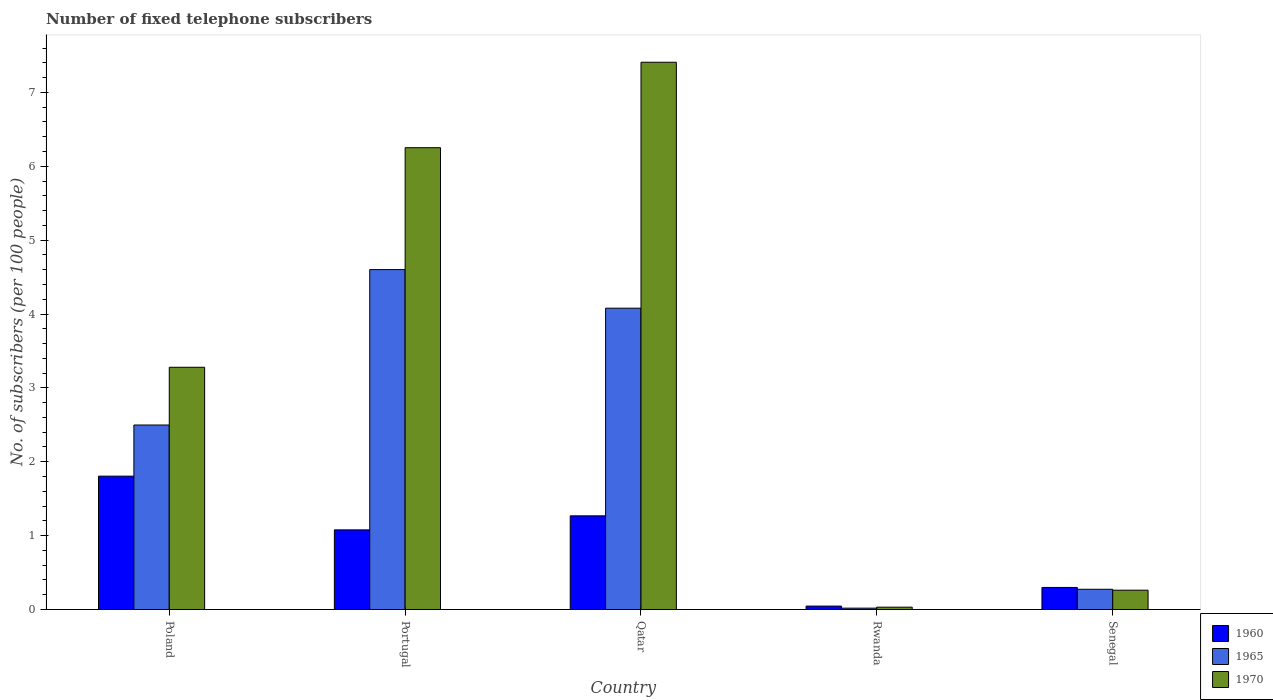Are the number of bars per tick equal to the number of legend labels?
Ensure brevity in your answer.  Yes. How many bars are there on the 4th tick from the left?
Provide a short and direct response. 3. How many bars are there on the 3rd tick from the right?
Make the answer very short. 3. What is the label of the 4th group of bars from the left?
Your answer should be very brief. Rwanda. What is the number of fixed telephone subscribers in 1970 in Qatar?
Your answer should be compact. 7.41. Across all countries, what is the maximum number of fixed telephone subscribers in 1960?
Your response must be concise. 1.81. Across all countries, what is the minimum number of fixed telephone subscribers in 1965?
Offer a very short reply. 0.02. In which country was the number of fixed telephone subscribers in 1965 maximum?
Offer a terse response. Portugal. In which country was the number of fixed telephone subscribers in 1970 minimum?
Give a very brief answer. Rwanda. What is the total number of fixed telephone subscribers in 1970 in the graph?
Provide a succinct answer. 17.23. What is the difference between the number of fixed telephone subscribers in 1965 in Poland and that in Qatar?
Give a very brief answer. -1.58. What is the difference between the number of fixed telephone subscribers in 1960 in Portugal and the number of fixed telephone subscribers in 1970 in Senegal?
Your answer should be very brief. 0.82. What is the average number of fixed telephone subscribers in 1965 per country?
Give a very brief answer. 2.29. What is the difference between the number of fixed telephone subscribers of/in 1970 and number of fixed telephone subscribers of/in 1965 in Poland?
Offer a terse response. 0.78. What is the ratio of the number of fixed telephone subscribers in 1960 in Portugal to that in Senegal?
Give a very brief answer. 3.61. What is the difference between the highest and the second highest number of fixed telephone subscribers in 1960?
Offer a very short reply. 0.54. What is the difference between the highest and the lowest number of fixed telephone subscribers in 1970?
Ensure brevity in your answer.  7.38. In how many countries, is the number of fixed telephone subscribers in 1960 greater than the average number of fixed telephone subscribers in 1960 taken over all countries?
Give a very brief answer. 3. Is the sum of the number of fixed telephone subscribers in 1970 in Poland and Portugal greater than the maximum number of fixed telephone subscribers in 1960 across all countries?
Provide a short and direct response. Yes. Is it the case that in every country, the sum of the number of fixed telephone subscribers in 1960 and number of fixed telephone subscribers in 1965 is greater than the number of fixed telephone subscribers in 1970?
Provide a succinct answer. No. How many countries are there in the graph?
Make the answer very short. 5. Are the values on the major ticks of Y-axis written in scientific E-notation?
Your response must be concise. No. Does the graph contain any zero values?
Offer a terse response. No. Does the graph contain grids?
Your response must be concise. No. Where does the legend appear in the graph?
Offer a terse response. Bottom right. How many legend labels are there?
Ensure brevity in your answer.  3. What is the title of the graph?
Make the answer very short. Number of fixed telephone subscribers. What is the label or title of the X-axis?
Provide a succinct answer. Country. What is the label or title of the Y-axis?
Make the answer very short. No. of subscribers (per 100 people). What is the No. of subscribers (per 100 people) in 1960 in Poland?
Give a very brief answer. 1.81. What is the No. of subscribers (per 100 people) of 1965 in Poland?
Your answer should be very brief. 2.5. What is the No. of subscribers (per 100 people) of 1970 in Poland?
Keep it short and to the point. 3.28. What is the No. of subscribers (per 100 people) of 1960 in Portugal?
Provide a succinct answer. 1.08. What is the No. of subscribers (per 100 people) of 1965 in Portugal?
Provide a short and direct response. 4.6. What is the No. of subscribers (per 100 people) in 1970 in Portugal?
Your response must be concise. 6.25. What is the No. of subscribers (per 100 people) in 1960 in Qatar?
Offer a terse response. 1.27. What is the No. of subscribers (per 100 people) of 1965 in Qatar?
Provide a succinct answer. 4.08. What is the No. of subscribers (per 100 people) in 1970 in Qatar?
Your answer should be very brief. 7.41. What is the No. of subscribers (per 100 people) of 1960 in Rwanda?
Offer a terse response. 0.05. What is the No. of subscribers (per 100 people) of 1965 in Rwanda?
Your answer should be very brief. 0.02. What is the No. of subscribers (per 100 people) in 1970 in Rwanda?
Your answer should be very brief. 0.03. What is the No. of subscribers (per 100 people) in 1960 in Senegal?
Your answer should be very brief. 0.3. What is the No. of subscribers (per 100 people) in 1965 in Senegal?
Offer a terse response. 0.27. What is the No. of subscribers (per 100 people) in 1970 in Senegal?
Offer a very short reply. 0.26. Across all countries, what is the maximum No. of subscribers (per 100 people) in 1960?
Give a very brief answer. 1.81. Across all countries, what is the maximum No. of subscribers (per 100 people) in 1965?
Your response must be concise. 4.6. Across all countries, what is the maximum No. of subscribers (per 100 people) in 1970?
Provide a short and direct response. 7.41. Across all countries, what is the minimum No. of subscribers (per 100 people) in 1960?
Offer a terse response. 0.05. Across all countries, what is the minimum No. of subscribers (per 100 people) in 1965?
Provide a succinct answer. 0.02. Across all countries, what is the minimum No. of subscribers (per 100 people) of 1970?
Keep it short and to the point. 0.03. What is the total No. of subscribers (per 100 people) of 1960 in the graph?
Give a very brief answer. 4.5. What is the total No. of subscribers (per 100 people) in 1965 in the graph?
Make the answer very short. 11.47. What is the total No. of subscribers (per 100 people) in 1970 in the graph?
Provide a succinct answer. 17.23. What is the difference between the No. of subscribers (per 100 people) in 1960 in Poland and that in Portugal?
Your response must be concise. 0.73. What is the difference between the No. of subscribers (per 100 people) in 1965 in Poland and that in Portugal?
Ensure brevity in your answer.  -2.1. What is the difference between the No. of subscribers (per 100 people) of 1970 in Poland and that in Portugal?
Your response must be concise. -2.97. What is the difference between the No. of subscribers (per 100 people) of 1960 in Poland and that in Qatar?
Provide a succinct answer. 0.54. What is the difference between the No. of subscribers (per 100 people) of 1965 in Poland and that in Qatar?
Provide a short and direct response. -1.58. What is the difference between the No. of subscribers (per 100 people) of 1970 in Poland and that in Qatar?
Offer a very short reply. -4.13. What is the difference between the No. of subscribers (per 100 people) of 1960 in Poland and that in Rwanda?
Provide a short and direct response. 1.76. What is the difference between the No. of subscribers (per 100 people) of 1965 in Poland and that in Rwanda?
Give a very brief answer. 2.48. What is the difference between the No. of subscribers (per 100 people) in 1970 in Poland and that in Rwanda?
Ensure brevity in your answer.  3.25. What is the difference between the No. of subscribers (per 100 people) in 1960 in Poland and that in Senegal?
Give a very brief answer. 1.51. What is the difference between the No. of subscribers (per 100 people) of 1965 in Poland and that in Senegal?
Offer a terse response. 2.22. What is the difference between the No. of subscribers (per 100 people) in 1970 in Poland and that in Senegal?
Provide a short and direct response. 3.02. What is the difference between the No. of subscribers (per 100 people) of 1960 in Portugal and that in Qatar?
Offer a terse response. -0.19. What is the difference between the No. of subscribers (per 100 people) in 1965 in Portugal and that in Qatar?
Your response must be concise. 0.52. What is the difference between the No. of subscribers (per 100 people) in 1970 in Portugal and that in Qatar?
Offer a very short reply. -1.16. What is the difference between the No. of subscribers (per 100 people) of 1960 in Portugal and that in Rwanda?
Your answer should be very brief. 1.03. What is the difference between the No. of subscribers (per 100 people) in 1965 in Portugal and that in Rwanda?
Your response must be concise. 4.58. What is the difference between the No. of subscribers (per 100 people) in 1970 in Portugal and that in Rwanda?
Your answer should be very brief. 6.22. What is the difference between the No. of subscribers (per 100 people) in 1960 in Portugal and that in Senegal?
Provide a short and direct response. 0.78. What is the difference between the No. of subscribers (per 100 people) of 1965 in Portugal and that in Senegal?
Give a very brief answer. 4.33. What is the difference between the No. of subscribers (per 100 people) of 1970 in Portugal and that in Senegal?
Your response must be concise. 5.99. What is the difference between the No. of subscribers (per 100 people) of 1960 in Qatar and that in Rwanda?
Offer a very short reply. 1.22. What is the difference between the No. of subscribers (per 100 people) of 1965 in Qatar and that in Rwanda?
Ensure brevity in your answer.  4.06. What is the difference between the No. of subscribers (per 100 people) in 1970 in Qatar and that in Rwanda?
Provide a succinct answer. 7.38. What is the difference between the No. of subscribers (per 100 people) in 1960 in Qatar and that in Senegal?
Ensure brevity in your answer.  0.97. What is the difference between the No. of subscribers (per 100 people) of 1965 in Qatar and that in Senegal?
Make the answer very short. 3.8. What is the difference between the No. of subscribers (per 100 people) of 1970 in Qatar and that in Senegal?
Your answer should be compact. 7.15. What is the difference between the No. of subscribers (per 100 people) of 1960 in Rwanda and that in Senegal?
Provide a short and direct response. -0.25. What is the difference between the No. of subscribers (per 100 people) in 1965 in Rwanda and that in Senegal?
Give a very brief answer. -0.26. What is the difference between the No. of subscribers (per 100 people) in 1970 in Rwanda and that in Senegal?
Make the answer very short. -0.23. What is the difference between the No. of subscribers (per 100 people) in 1960 in Poland and the No. of subscribers (per 100 people) in 1965 in Portugal?
Give a very brief answer. -2.8. What is the difference between the No. of subscribers (per 100 people) of 1960 in Poland and the No. of subscribers (per 100 people) of 1970 in Portugal?
Make the answer very short. -4.45. What is the difference between the No. of subscribers (per 100 people) in 1965 in Poland and the No. of subscribers (per 100 people) in 1970 in Portugal?
Offer a terse response. -3.75. What is the difference between the No. of subscribers (per 100 people) of 1960 in Poland and the No. of subscribers (per 100 people) of 1965 in Qatar?
Provide a succinct answer. -2.27. What is the difference between the No. of subscribers (per 100 people) in 1960 in Poland and the No. of subscribers (per 100 people) in 1970 in Qatar?
Give a very brief answer. -5.6. What is the difference between the No. of subscribers (per 100 people) of 1965 in Poland and the No. of subscribers (per 100 people) of 1970 in Qatar?
Your answer should be compact. -4.91. What is the difference between the No. of subscribers (per 100 people) in 1960 in Poland and the No. of subscribers (per 100 people) in 1965 in Rwanda?
Offer a terse response. 1.79. What is the difference between the No. of subscribers (per 100 people) in 1960 in Poland and the No. of subscribers (per 100 people) in 1970 in Rwanda?
Provide a succinct answer. 1.77. What is the difference between the No. of subscribers (per 100 people) of 1965 in Poland and the No. of subscribers (per 100 people) of 1970 in Rwanda?
Your answer should be very brief. 2.47. What is the difference between the No. of subscribers (per 100 people) of 1960 in Poland and the No. of subscribers (per 100 people) of 1965 in Senegal?
Provide a short and direct response. 1.53. What is the difference between the No. of subscribers (per 100 people) of 1960 in Poland and the No. of subscribers (per 100 people) of 1970 in Senegal?
Your answer should be very brief. 1.54. What is the difference between the No. of subscribers (per 100 people) of 1965 in Poland and the No. of subscribers (per 100 people) of 1970 in Senegal?
Ensure brevity in your answer.  2.24. What is the difference between the No. of subscribers (per 100 people) of 1960 in Portugal and the No. of subscribers (per 100 people) of 1965 in Qatar?
Your response must be concise. -3. What is the difference between the No. of subscribers (per 100 people) in 1960 in Portugal and the No. of subscribers (per 100 people) in 1970 in Qatar?
Your response must be concise. -6.33. What is the difference between the No. of subscribers (per 100 people) in 1965 in Portugal and the No. of subscribers (per 100 people) in 1970 in Qatar?
Provide a succinct answer. -2.81. What is the difference between the No. of subscribers (per 100 people) in 1960 in Portugal and the No. of subscribers (per 100 people) in 1965 in Rwanda?
Your response must be concise. 1.06. What is the difference between the No. of subscribers (per 100 people) in 1960 in Portugal and the No. of subscribers (per 100 people) in 1970 in Rwanda?
Keep it short and to the point. 1.05. What is the difference between the No. of subscribers (per 100 people) in 1965 in Portugal and the No. of subscribers (per 100 people) in 1970 in Rwanda?
Your answer should be very brief. 4.57. What is the difference between the No. of subscribers (per 100 people) in 1960 in Portugal and the No. of subscribers (per 100 people) in 1965 in Senegal?
Your answer should be very brief. 0.8. What is the difference between the No. of subscribers (per 100 people) in 1960 in Portugal and the No. of subscribers (per 100 people) in 1970 in Senegal?
Keep it short and to the point. 0.82. What is the difference between the No. of subscribers (per 100 people) in 1965 in Portugal and the No. of subscribers (per 100 people) in 1970 in Senegal?
Provide a short and direct response. 4.34. What is the difference between the No. of subscribers (per 100 people) in 1960 in Qatar and the No. of subscribers (per 100 people) in 1965 in Rwanda?
Keep it short and to the point. 1.25. What is the difference between the No. of subscribers (per 100 people) of 1960 in Qatar and the No. of subscribers (per 100 people) of 1970 in Rwanda?
Provide a short and direct response. 1.24. What is the difference between the No. of subscribers (per 100 people) of 1965 in Qatar and the No. of subscribers (per 100 people) of 1970 in Rwanda?
Provide a short and direct response. 4.05. What is the difference between the No. of subscribers (per 100 people) in 1960 in Qatar and the No. of subscribers (per 100 people) in 1970 in Senegal?
Offer a very short reply. 1.01. What is the difference between the No. of subscribers (per 100 people) in 1965 in Qatar and the No. of subscribers (per 100 people) in 1970 in Senegal?
Offer a very short reply. 3.82. What is the difference between the No. of subscribers (per 100 people) of 1960 in Rwanda and the No. of subscribers (per 100 people) of 1965 in Senegal?
Provide a short and direct response. -0.23. What is the difference between the No. of subscribers (per 100 people) of 1960 in Rwanda and the No. of subscribers (per 100 people) of 1970 in Senegal?
Offer a very short reply. -0.22. What is the difference between the No. of subscribers (per 100 people) in 1965 in Rwanda and the No. of subscribers (per 100 people) in 1970 in Senegal?
Your answer should be very brief. -0.24. What is the average No. of subscribers (per 100 people) of 1960 per country?
Your answer should be compact. 0.9. What is the average No. of subscribers (per 100 people) of 1965 per country?
Make the answer very short. 2.29. What is the average No. of subscribers (per 100 people) of 1970 per country?
Your response must be concise. 3.45. What is the difference between the No. of subscribers (per 100 people) in 1960 and No. of subscribers (per 100 people) in 1965 in Poland?
Make the answer very short. -0.69. What is the difference between the No. of subscribers (per 100 people) of 1960 and No. of subscribers (per 100 people) of 1970 in Poland?
Ensure brevity in your answer.  -1.47. What is the difference between the No. of subscribers (per 100 people) in 1965 and No. of subscribers (per 100 people) in 1970 in Poland?
Make the answer very short. -0.78. What is the difference between the No. of subscribers (per 100 people) of 1960 and No. of subscribers (per 100 people) of 1965 in Portugal?
Make the answer very short. -3.52. What is the difference between the No. of subscribers (per 100 people) in 1960 and No. of subscribers (per 100 people) in 1970 in Portugal?
Keep it short and to the point. -5.17. What is the difference between the No. of subscribers (per 100 people) of 1965 and No. of subscribers (per 100 people) of 1970 in Portugal?
Offer a terse response. -1.65. What is the difference between the No. of subscribers (per 100 people) of 1960 and No. of subscribers (per 100 people) of 1965 in Qatar?
Provide a succinct answer. -2.81. What is the difference between the No. of subscribers (per 100 people) of 1960 and No. of subscribers (per 100 people) of 1970 in Qatar?
Your response must be concise. -6.14. What is the difference between the No. of subscribers (per 100 people) in 1965 and No. of subscribers (per 100 people) in 1970 in Qatar?
Offer a very short reply. -3.33. What is the difference between the No. of subscribers (per 100 people) in 1960 and No. of subscribers (per 100 people) in 1965 in Rwanda?
Keep it short and to the point. 0.03. What is the difference between the No. of subscribers (per 100 people) in 1960 and No. of subscribers (per 100 people) in 1970 in Rwanda?
Your answer should be compact. 0.01. What is the difference between the No. of subscribers (per 100 people) in 1965 and No. of subscribers (per 100 people) in 1970 in Rwanda?
Make the answer very short. -0.01. What is the difference between the No. of subscribers (per 100 people) of 1960 and No. of subscribers (per 100 people) of 1965 in Senegal?
Your answer should be compact. 0.02. What is the difference between the No. of subscribers (per 100 people) in 1960 and No. of subscribers (per 100 people) in 1970 in Senegal?
Ensure brevity in your answer.  0.04. What is the difference between the No. of subscribers (per 100 people) in 1965 and No. of subscribers (per 100 people) in 1970 in Senegal?
Make the answer very short. 0.01. What is the ratio of the No. of subscribers (per 100 people) of 1960 in Poland to that in Portugal?
Provide a succinct answer. 1.67. What is the ratio of the No. of subscribers (per 100 people) in 1965 in Poland to that in Portugal?
Your answer should be compact. 0.54. What is the ratio of the No. of subscribers (per 100 people) of 1970 in Poland to that in Portugal?
Offer a terse response. 0.52. What is the ratio of the No. of subscribers (per 100 people) in 1960 in Poland to that in Qatar?
Offer a very short reply. 1.42. What is the ratio of the No. of subscribers (per 100 people) in 1965 in Poland to that in Qatar?
Offer a terse response. 0.61. What is the ratio of the No. of subscribers (per 100 people) of 1970 in Poland to that in Qatar?
Your answer should be compact. 0.44. What is the ratio of the No. of subscribers (per 100 people) in 1960 in Poland to that in Rwanda?
Your answer should be very brief. 38.77. What is the ratio of the No. of subscribers (per 100 people) of 1965 in Poland to that in Rwanda?
Offer a terse response. 134.57. What is the ratio of the No. of subscribers (per 100 people) of 1970 in Poland to that in Rwanda?
Offer a terse response. 102.59. What is the ratio of the No. of subscribers (per 100 people) in 1960 in Poland to that in Senegal?
Your response must be concise. 6.04. What is the ratio of the No. of subscribers (per 100 people) in 1965 in Poland to that in Senegal?
Your answer should be very brief. 9.11. What is the ratio of the No. of subscribers (per 100 people) of 1970 in Poland to that in Senegal?
Provide a succinct answer. 12.53. What is the ratio of the No. of subscribers (per 100 people) of 1960 in Portugal to that in Qatar?
Give a very brief answer. 0.85. What is the ratio of the No. of subscribers (per 100 people) in 1965 in Portugal to that in Qatar?
Offer a very short reply. 1.13. What is the ratio of the No. of subscribers (per 100 people) in 1970 in Portugal to that in Qatar?
Ensure brevity in your answer.  0.84. What is the ratio of the No. of subscribers (per 100 people) of 1960 in Portugal to that in Rwanda?
Your answer should be very brief. 23.15. What is the ratio of the No. of subscribers (per 100 people) in 1965 in Portugal to that in Rwanda?
Your response must be concise. 247.93. What is the ratio of the No. of subscribers (per 100 people) of 1970 in Portugal to that in Rwanda?
Offer a very short reply. 195.59. What is the ratio of the No. of subscribers (per 100 people) of 1960 in Portugal to that in Senegal?
Offer a terse response. 3.61. What is the ratio of the No. of subscribers (per 100 people) in 1965 in Portugal to that in Senegal?
Provide a succinct answer. 16.79. What is the ratio of the No. of subscribers (per 100 people) in 1970 in Portugal to that in Senegal?
Your response must be concise. 23.89. What is the ratio of the No. of subscribers (per 100 people) of 1960 in Qatar to that in Rwanda?
Give a very brief answer. 27.23. What is the ratio of the No. of subscribers (per 100 people) of 1965 in Qatar to that in Rwanda?
Your answer should be compact. 219.77. What is the ratio of the No. of subscribers (per 100 people) of 1970 in Qatar to that in Rwanda?
Offer a very short reply. 231.78. What is the ratio of the No. of subscribers (per 100 people) of 1960 in Qatar to that in Senegal?
Offer a very short reply. 4.24. What is the ratio of the No. of subscribers (per 100 people) of 1965 in Qatar to that in Senegal?
Provide a short and direct response. 14.88. What is the ratio of the No. of subscribers (per 100 people) of 1970 in Qatar to that in Senegal?
Provide a succinct answer. 28.31. What is the ratio of the No. of subscribers (per 100 people) in 1960 in Rwanda to that in Senegal?
Ensure brevity in your answer.  0.16. What is the ratio of the No. of subscribers (per 100 people) of 1965 in Rwanda to that in Senegal?
Your response must be concise. 0.07. What is the ratio of the No. of subscribers (per 100 people) in 1970 in Rwanda to that in Senegal?
Your response must be concise. 0.12. What is the difference between the highest and the second highest No. of subscribers (per 100 people) in 1960?
Keep it short and to the point. 0.54. What is the difference between the highest and the second highest No. of subscribers (per 100 people) of 1965?
Provide a succinct answer. 0.52. What is the difference between the highest and the second highest No. of subscribers (per 100 people) of 1970?
Give a very brief answer. 1.16. What is the difference between the highest and the lowest No. of subscribers (per 100 people) in 1960?
Offer a very short reply. 1.76. What is the difference between the highest and the lowest No. of subscribers (per 100 people) of 1965?
Make the answer very short. 4.58. What is the difference between the highest and the lowest No. of subscribers (per 100 people) of 1970?
Offer a terse response. 7.38. 